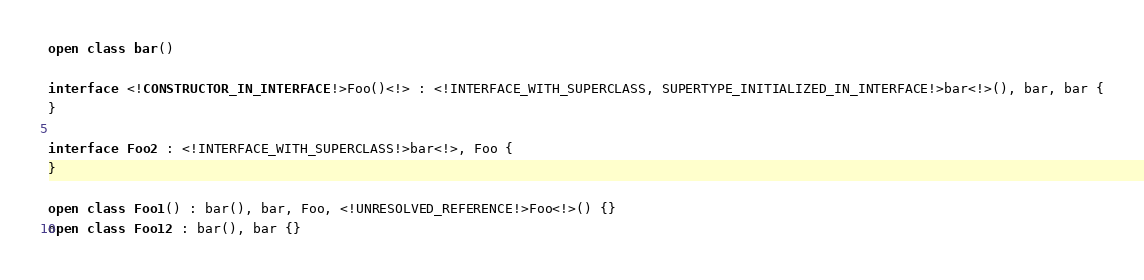Convert code to text. <code><loc_0><loc_0><loc_500><loc_500><_Kotlin_>open class bar()

interface <!CONSTRUCTOR_IN_INTERFACE!>Foo()<!> : <!INTERFACE_WITH_SUPERCLASS, SUPERTYPE_INITIALIZED_IN_INTERFACE!>bar<!>(), bar, bar {
}

interface Foo2 : <!INTERFACE_WITH_SUPERCLASS!>bar<!>, Foo {
}

open class Foo1() : bar(), bar, Foo, <!UNRESOLVED_REFERENCE!>Foo<!>() {}
open class Foo12 : bar(), bar {}</code> 